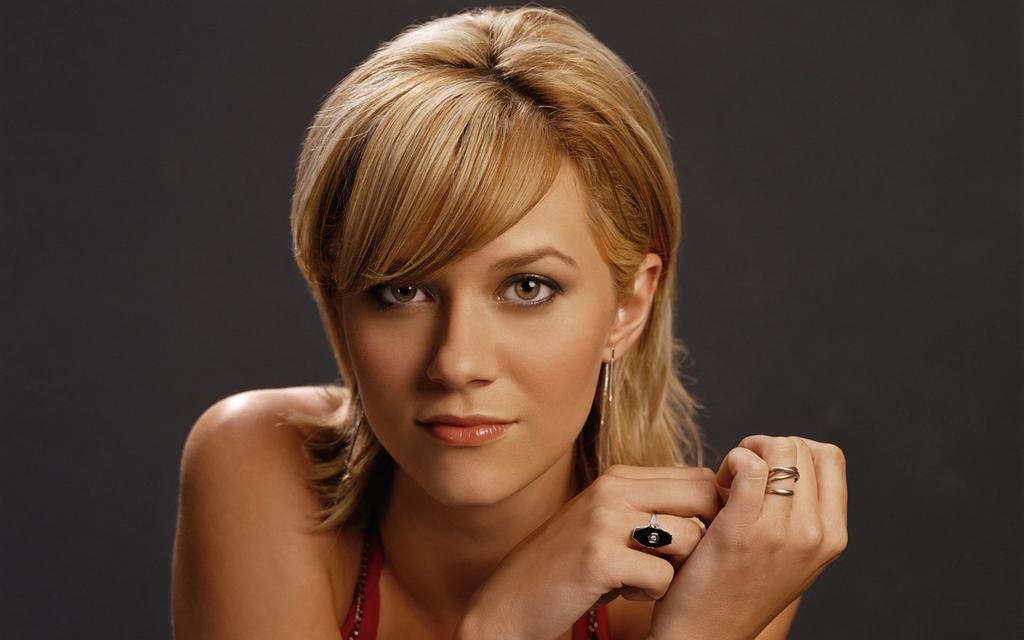How would you summarize this image in a sentence or two? The picture consists of a woman. The background is black. 